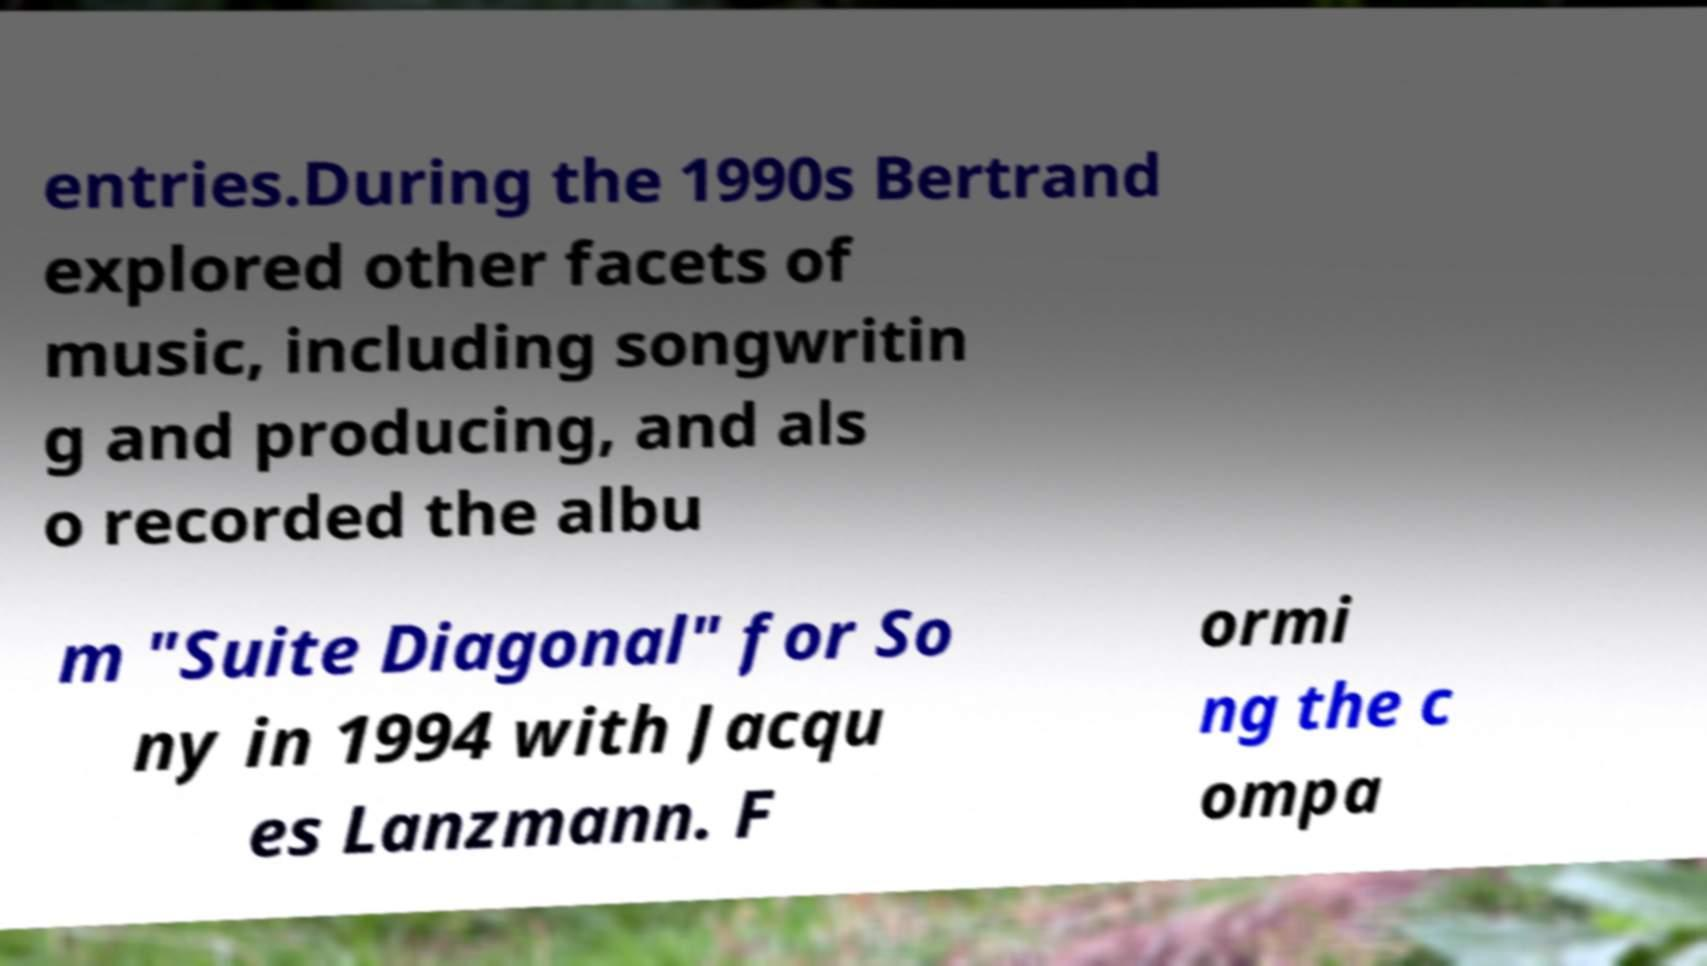Please identify and transcribe the text found in this image. entries.During the 1990s Bertrand explored other facets of music, including songwritin g and producing, and als o recorded the albu m "Suite Diagonal" for So ny in 1994 with Jacqu es Lanzmann. F ormi ng the c ompa 